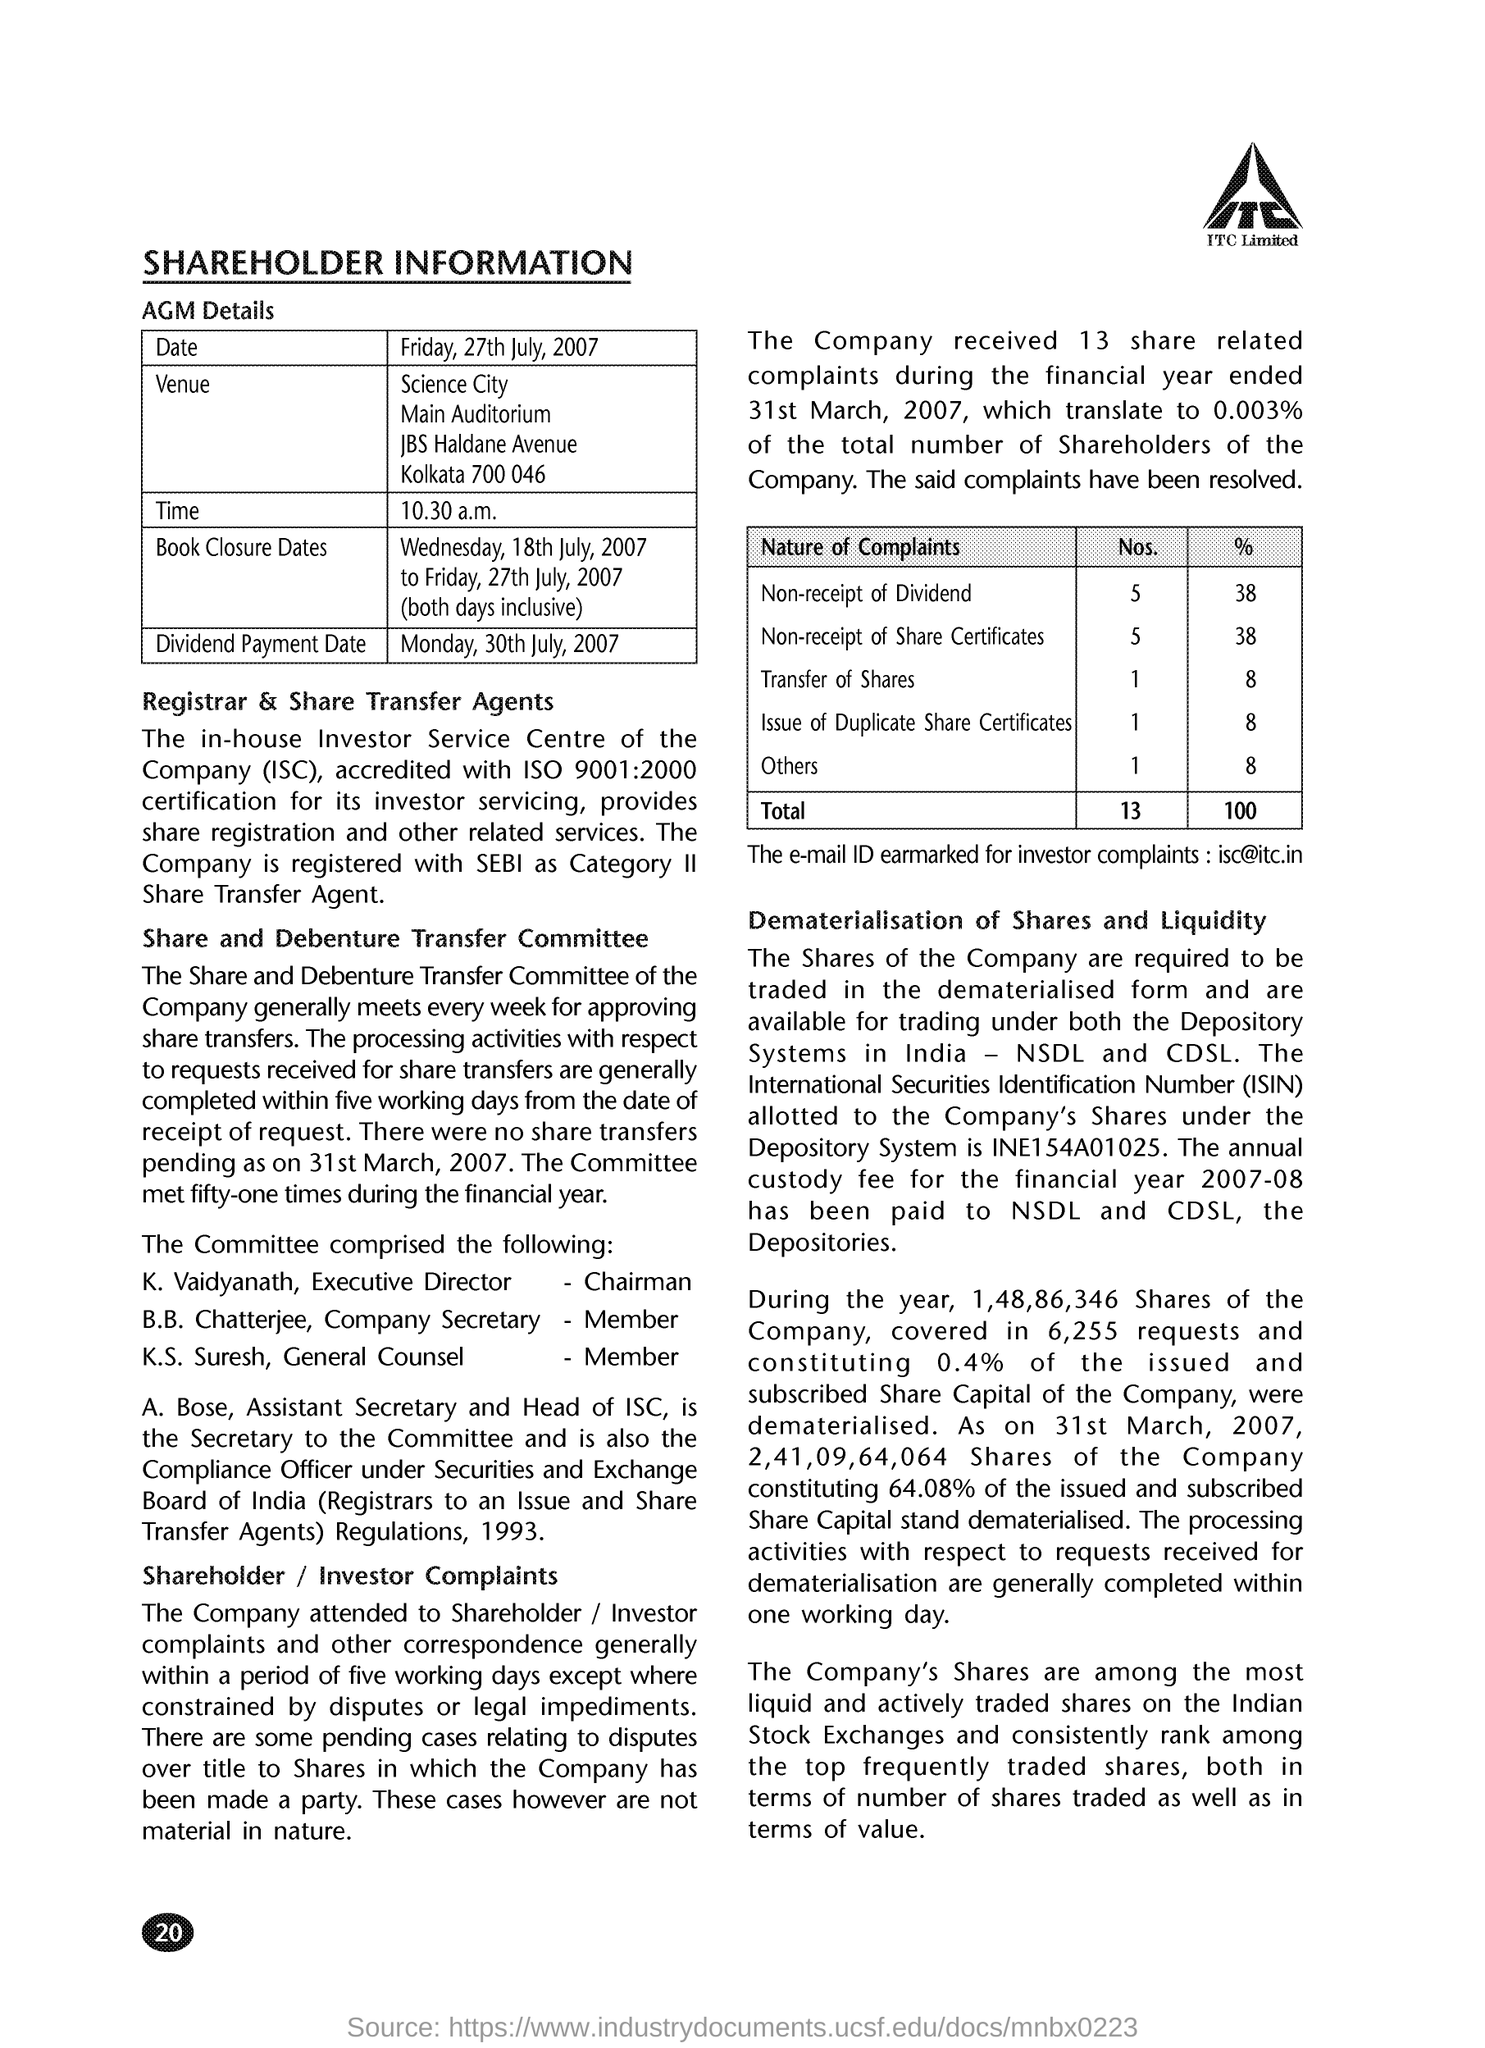List a handful of essential elements in this visual. The email address for investor complaints at ITC is [isc@itc.in](mailto:isc@itc.in). General Counsel member K.S. Suresh has been identified. 